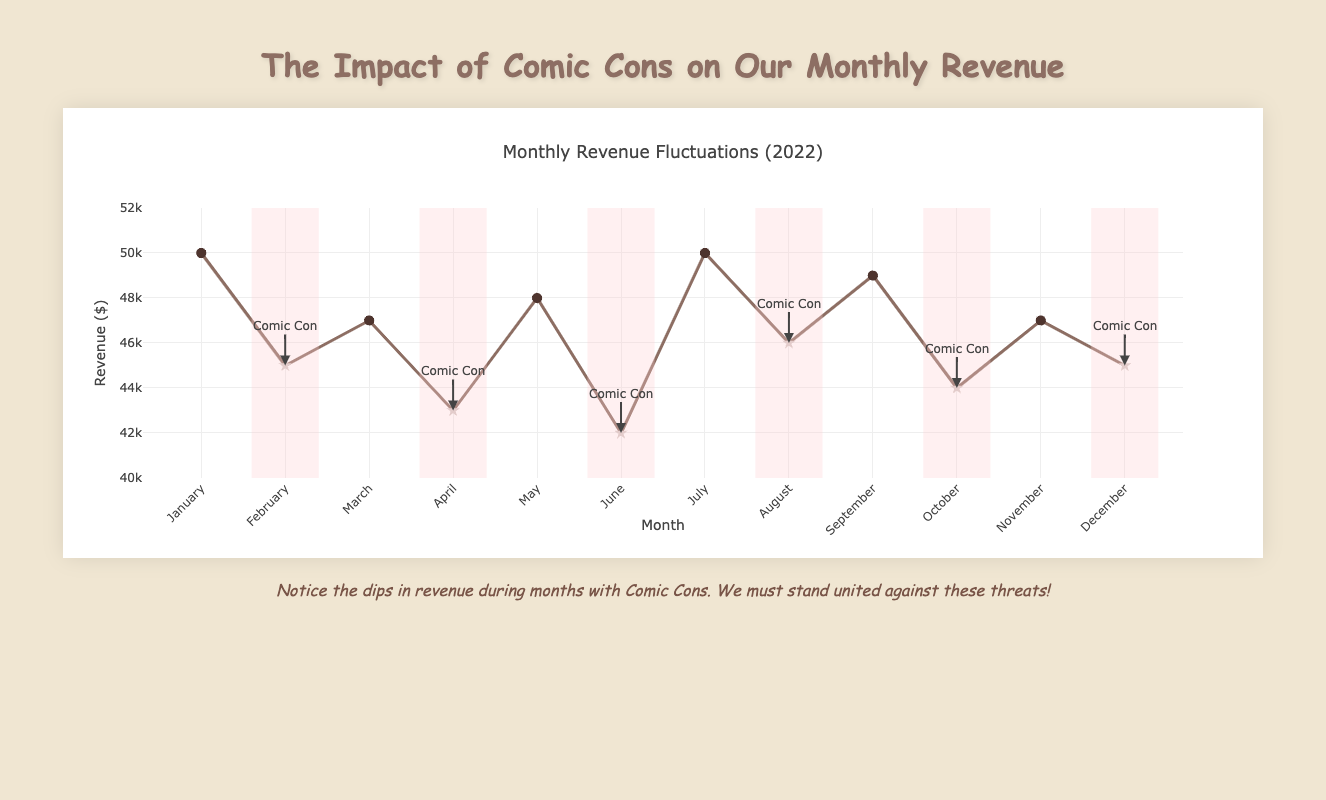What is the difference in revenue between the month with the highest revenue and the month with the lowest revenue? To find the difference, identify the highest and lowest revenue months. July has the highest revenue ($50,000) and June the lowest ($42,000). The difference is $50,000 - $42,000.
Answer: $8,000 Which months with Comic Cons had the lowest and highest revenues? We need to find months with Comic Cons and compare their revenues. The months with Comic Cons are February, April, June, August, October, and December. June has the lowest revenue ($42,000) and February the highest ($45,000).
Answer: June and February In which months do we see a significant drop in revenue after a Comic Con event? Compare the months following Comic Cons with their preceding months. Comic Cons are in February, April, June, August, October, and December. Significant drops are seen in March ($47,000) after February ($45,000), July ($50,000) after June ($42,000), and November ($47,000) after October ($44,000).
Answer: March, July, and November What's the average monthly revenue for months without Comic Cons? Calculate the average using revenues from months without Comic Cons: January ($50,000), March ($47,000), May ($48,000), July ($50,000), September ($49,000), and November ($47,000). The sum is $291,000, divide by 6.
Answer: $48,500 How does the revenue change visually during months with and without Comic Cons? Compare the colors and heights of markers. Darker colors (without Comic Cons) generally have higher marks, while lighter colors (with Comic Cons) show a trend of lower heights/revenues.
Answer: Darker markers have higher revenues What can we infer about the impact of local events on revenue compared to Comic Cons? Look at revenues in months with only local events (January, March, May, July, September, November) versus Comic Con months. Local-only months show higher revenue trends, suggesting Comic Cons have a greater negative impact.
Answer: Local events correlate with higher revenue Is there any month where both a local event and a Comic Con didn't cause a significant drop in revenue? Check months with both events for severe drops. December (Holiday Market and Winter Comic Con) has a higher than expected revenue drop but not as drastic as others.
Answer: December Which month shows the sharpest decline in revenue due to a Comic Con? Identify months with the steepest revenue drop after a Comic Con. April, with a drop to $43,000 from March's $47,000, shows a significant decline.
Answer: April 